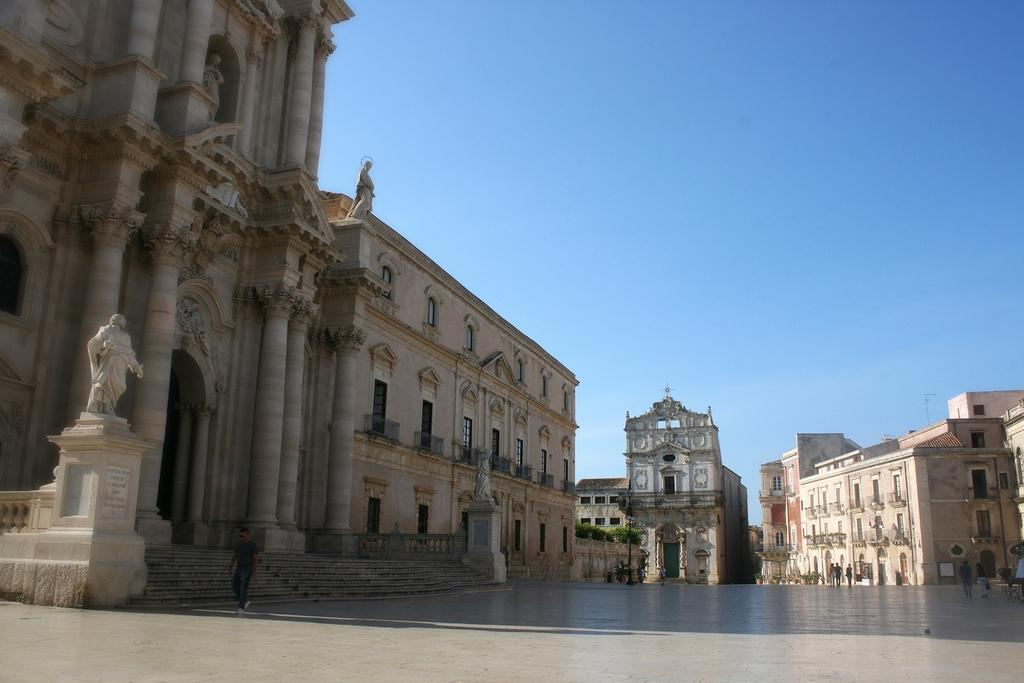What type of structures can be seen in the image? There are buildings in the image. What artistic elements are present in the image? There are sculptures in the image. Where are the people located in the image? The people are on the right side of the image. What type of vegetation can be seen in the background of the image? There are bushes in the background of the image. What is visible in the sky in the image? The sky is visible in the background of the image. What type of yarn is being used by the committee in the image? There is no committee or yarn present in the image. What idea is being discussed by the people in the image? The image does not provide any information about what the people might be discussing or thinking about. 